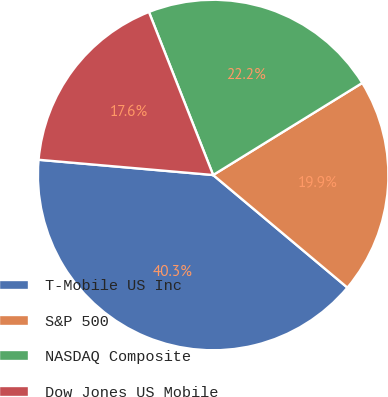Convert chart to OTSL. <chart><loc_0><loc_0><loc_500><loc_500><pie_chart><fcel>T-Mobile US Inc<fcel>S&P 500<fcel>NASDAQ Composite<fcel>Dow Jones US Mobile<nl><fcel>40.28%<fcel>19.91%<fcel>22.17%<fcel>17.64%<nl></chart> 